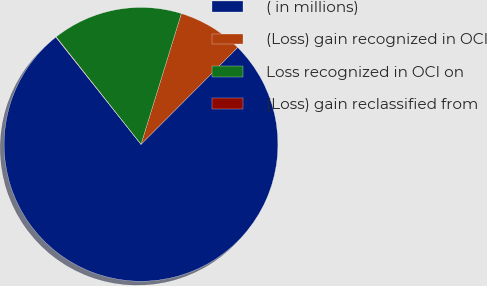<chart> <loc_0><loc_0><loc_500><loc_500><pie_chart><fcel>( in millions)<fcel>(Loss) gain recognized in OCI<fcel>Loss recognized in OCI on<fcel>(Loss) gain reclassified from<nl><fcel>76.84%<fcel>7.72%<fcel>15.4%<fcel>0.04%<nl></chart> 